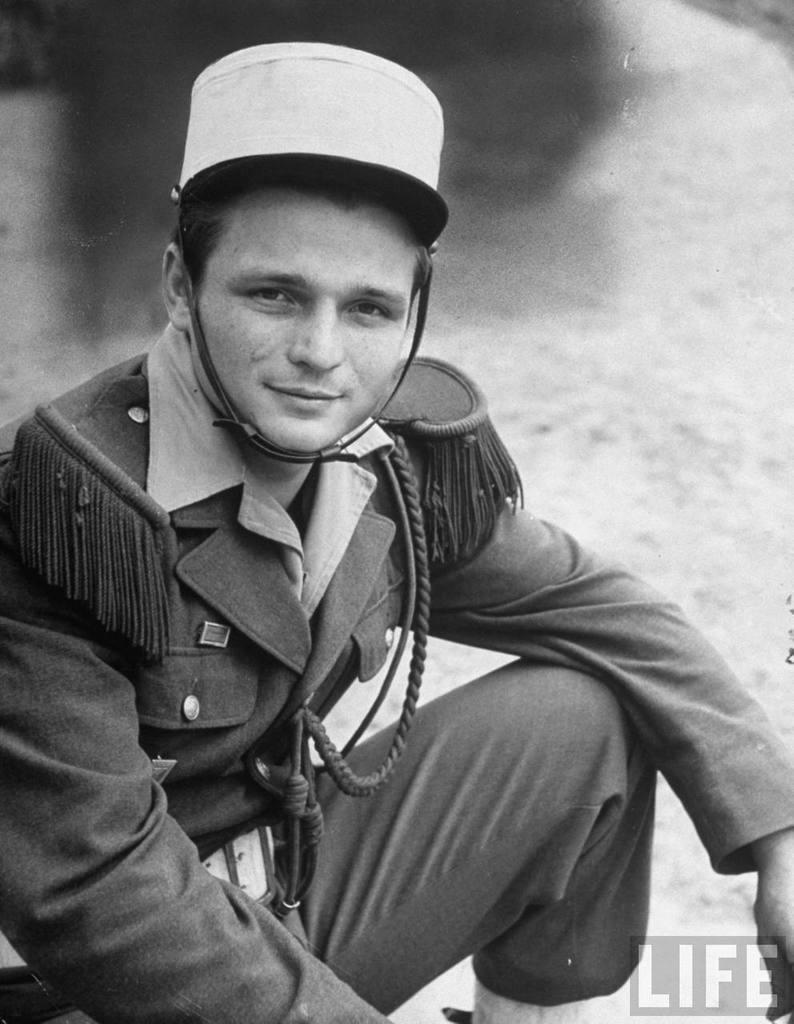What is the color scheme of the picture? The picture is black and white. Who or what is the main subject in the picture? There is a man in the picture. Is there any additional information or markings in the picture? Yes, there is a watermark in the bottom right corner of the picture. Can you describe the hen that is crossing the bridge in the picture? There is no hen or bridge present in the picture; it features a black and white image of a man. 